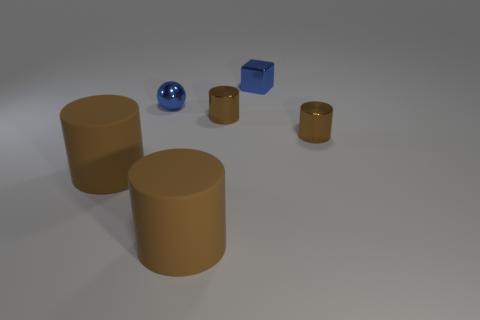How many brown cylinders must be subtracted to get 2 brown cylinders? 2 Add 3 tiny metal cylinders. How many objects exist? 9 Subtract all gray cylinders. Subtract all green spheres. How many cylinders are left? 4 Subtract all blocks. How many objects are left? 5 Subtract 0 green cylinders. How many objects are left? 6 Subtract all small blue cubes. Subtract all big rubber things. How many objects are left? 3 Add 1 blue things. How many blue things are left? 3 Add 3 purple metal cylinders. How many purple metal cylinders exist? 3 